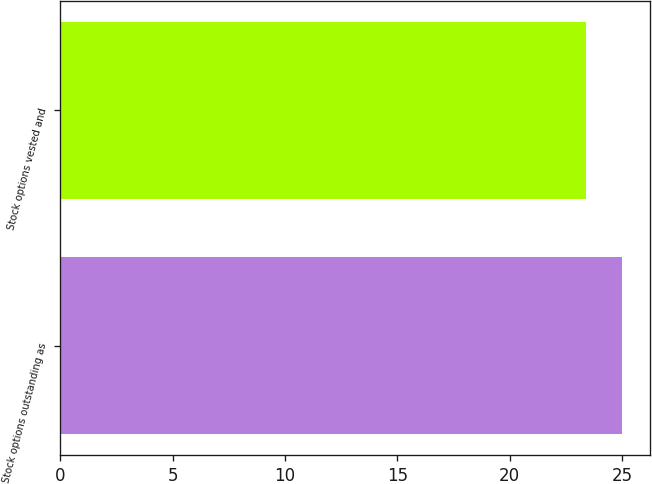Convert chart. <chart><loc_0><loc_0><loc_500><loc_500><bar_chart><fcel>Stock options outstanding as<fcel>Stock options vested and<nl><fcel>25<fcel>23.4<nl></chart> 